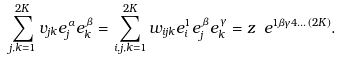Convert formula to latex. <formula><loc_0><loc_0><loc_500><loc_500>\sum _ { j , k = 1 } ^ { 2 K } v _ { j k } e ^ { \, \alpha } _ { j } e ^ { \, \beta } _ { k } = \sum _ { i , j , k = 1 } ^ { 2 K } w _ { i j k } e ^ { 1 } _ { i } e ^ { \, \beta } _ { j } e ^ { \, \gamma } _ { k } = z \ e ^ { 1 \beta \gamma 4 \dots ( 2 K ) } .</formula> 